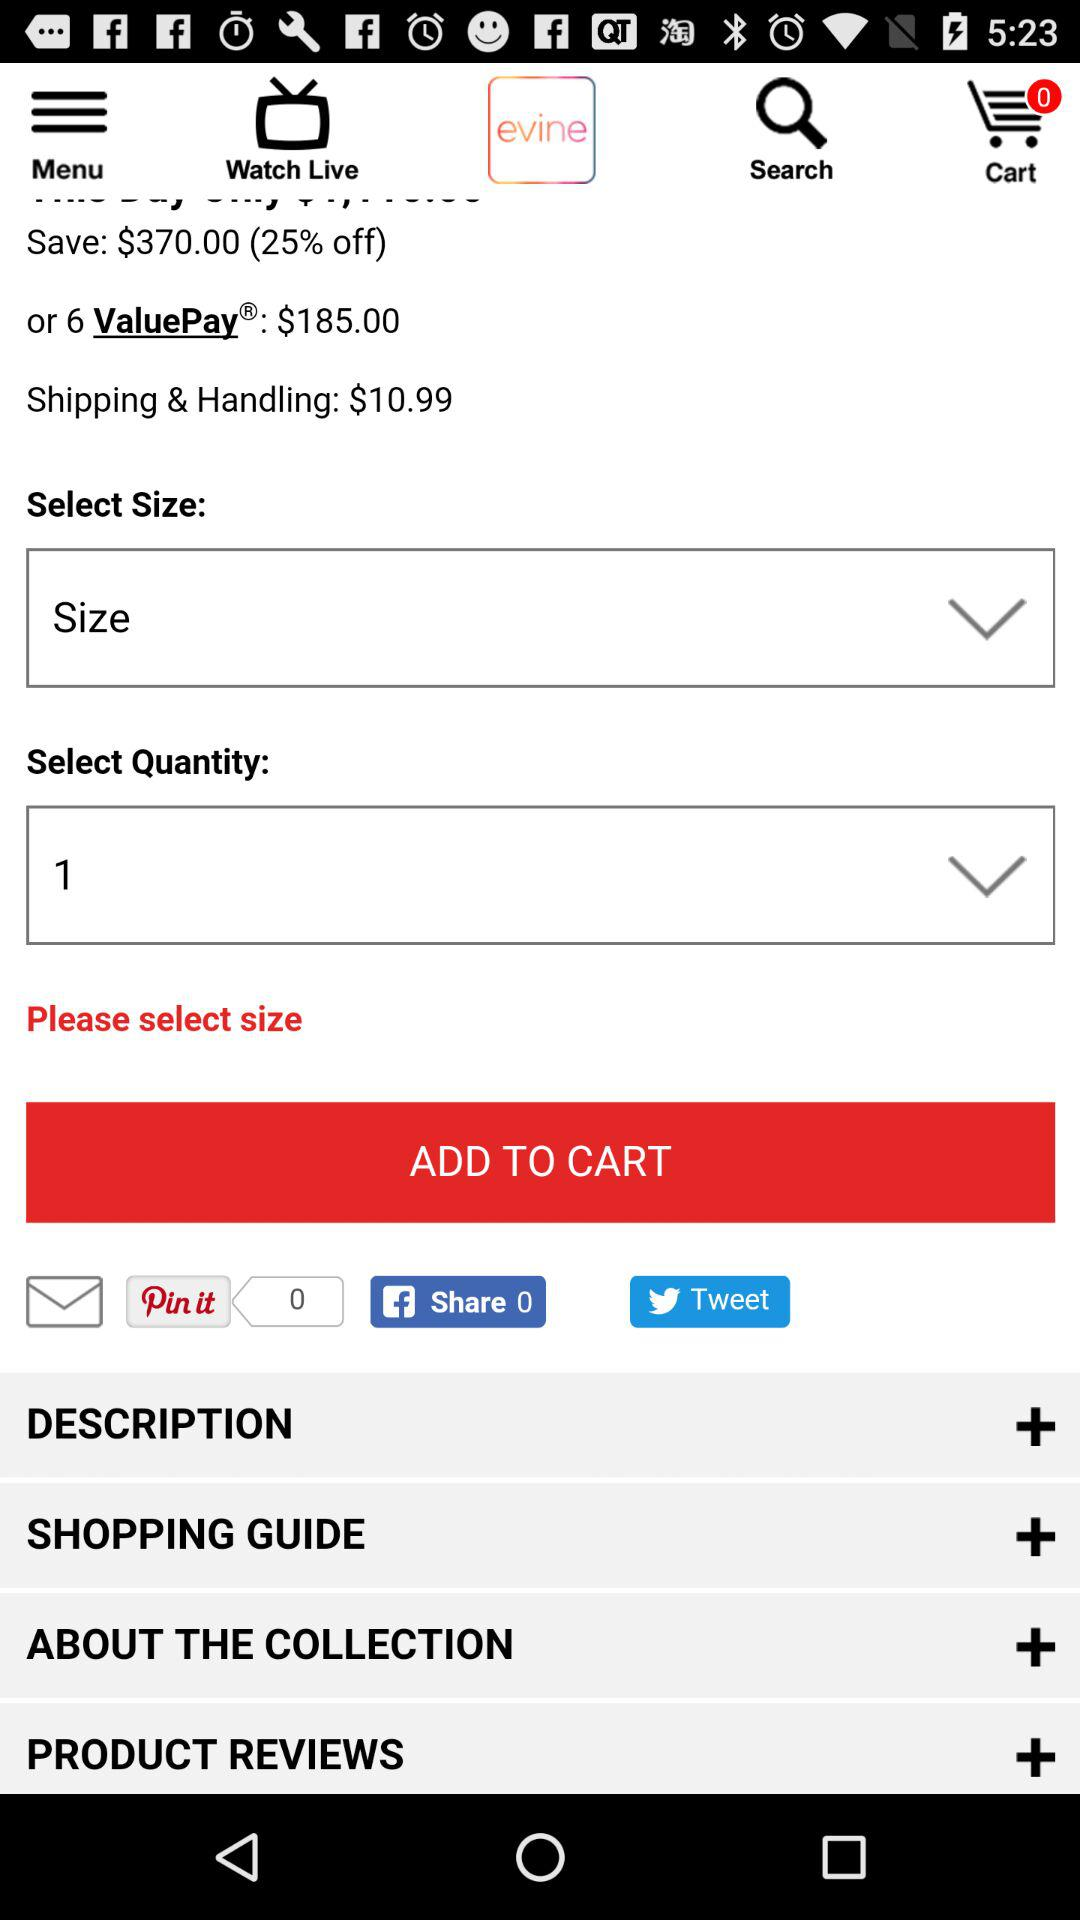How much is the shipping and handling charge?
Answer the question using a single word or phrase. $10.99 